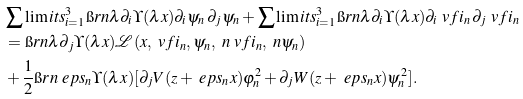Convert formula to latex. <formula><loc_0><loc_0><loc_500><loc_500>& \sum \lim i t s ^ { 3 } _ { i = 1 } \i r n \lambda \partial _ { i } \Upsilon ( \lambda x ) \partial _ { i } \psi _ { n } \, \partial _ { j } \psi _ { n } + \sum \lim i t s ^ { 3 } _ { i = 1 } \i r n \lambda \partial _ { i } \Upsilon ( \lambda x ) \partial _ { i } \ v f i _ { n } \, \partial _ { j } \ v f i _ { n } \\ & = \i r n \lambda \partial _ { j } \Upsilon ( \lambda x ) { \mathcal { L } } ( x , \ v f i _ { n } , \psi _ { n } , \ n \ v f i _ { n } , \ n \psi _ { n } ) \\ & + \frac { 1 } { 2 } \i r n \ e p s _ { n } \Upsilon ( \lambda x ) [ \partial _ { j } V ( z + \ e p s _ { n } x ) \varphi _ { n } ^ { 2 } + \partial _ { j } W ( z + \ e p s _ { n } x ) \psi _ { n } ^ { 2 } ] .</formula> 